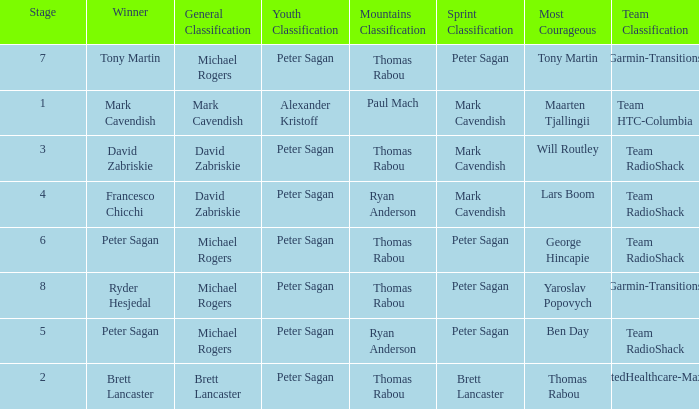When Brett Lancaster won the general classification, who won the team calssification? UnitedHealthcare-Maxxis. 